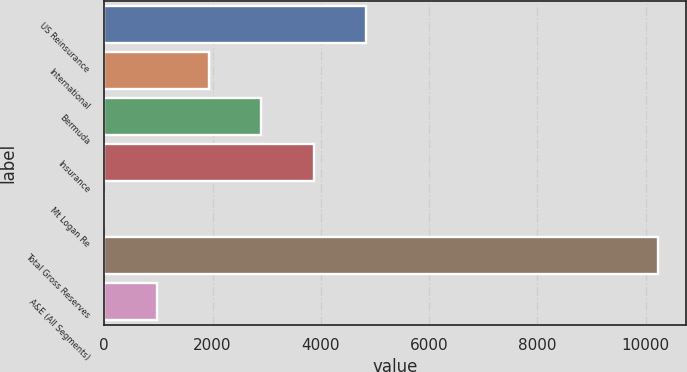Convert chart. <chart><loc_0><loc_0><loc_500><loc_500><bar_chart><fcel>US Reinsurance<fcel>International<fcel>Bermuda<fcel>Insurance<fcel>Mt Logan Re<fcel>Total Gross Reserves<fcel>A&E (All Segments)<nl><fcel>4838.75<fcel>1938.08<fcel>2904.97<fcel>3871.86<fcel>4.3<fcel>10237.7<fcel>971.19<nl></chart> 